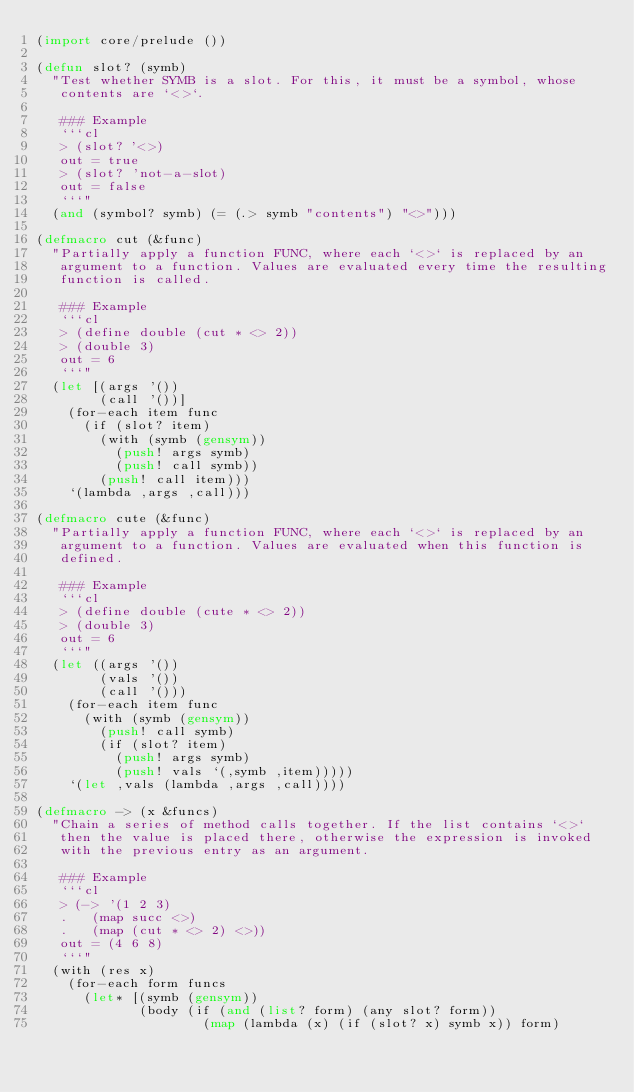<code> <loc_0><loc_0><loc_500><loc_500><_Lisp_>(import core/prelude ())

(defun slot? (symb)
  "Test whether SYMB is a slot. For this, it must be a symbol, whose
   contents are `<>`.

   ### Example
   ```cl
   > (slot? '<>)
   out = true
   > (slot? 'not-a-slot)
   out = false
   ```"
  (and (symbol? symb) (= (.> symb "contents") "<>")))

(defmacro cut (&func)
  "Partially apply a function FUNC, where each `<>` is replaced by an
   argument to a function. Values are evaluated every time the resulting
   function is called.

   ### Example
   ```cl
   > (define double (cut * <> 2))
   > (double 3)
   out = 6
   ```"
  (let [(args '())
        (call '())]
    (for-each item func
      (if (slot? item)
        (with (symb (gensym))
          (push! args symb)
          (push! call symb))
        (push! call item)))
    `(lambda ,args ,call)))

(defmacro cute (&func)
  "Partially apply a function FUNC, where each `<>` is replaced by an
   argument to a function. Values are evaluated when this function is
   defined.

   ### Example
   ```cl
   > (define double (cute * <> 2))
   > (double 3)
   out = 6
   ```"
  (let ((args '())
        (vals '())
        (call '()))
    (for-each item func
      (with (symb (gensym))
        (push! call symb)
        (if (slot? item)
          (push! args symb)
          (push! vals `(,symb ,item)))))
    `(let ,vals (lambda ,args ,call))))

(defmacro -> (x &funcs)
  "Chain a series of method calls together. If the list contains `<>`
   then the value is placed there, otherwise the expression is invoked
   with the previous entry as an argument.

   ### Example
   ```cl
   > (-> '(1 2 3)
   .   (map succ <>)
   .   (map (cut * <> 2) <>))
   out = (4 6 8)
   ```"
  (with (res x)
    (for-each form funcs
      (let* [(symb (gensym))
             (body (if (and (list? form) (any slot? form))
                     (map (lambda (x) (if (slot? x) symb x)) form)</code> 